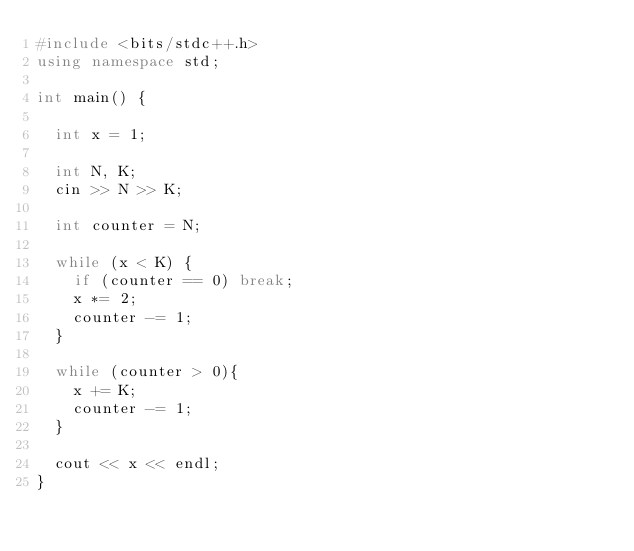<code> <loc_0><loc_0><loc_500><loc_500><_C++_>#include <bits/stdc++.h>
using namespace std;

int main() {
  
  int x = 1;
  
  int N, K;
  cin >> N >> K;
  
  int counter = N;
  
  while (x < K) {
    if (counter == 0) break;
    x *= 2;
    counter -= 1;
  }
  
  while (counter > 0){
    x += K;
    counter -= 1;
  }
  
  cout << x << endl;
}</code> 